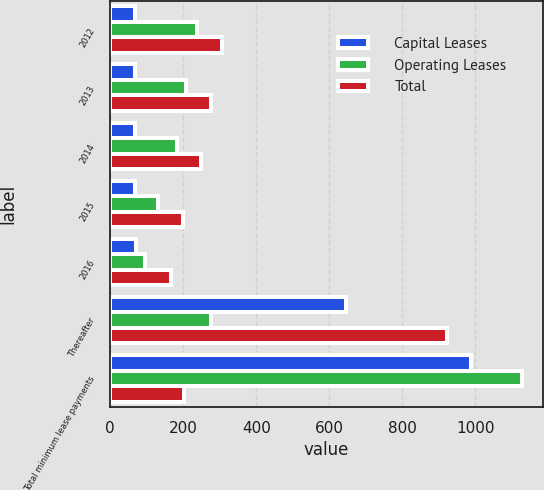Convert chart to OTSL. <chart><loc_0><loc_0><loc_500><loc_500><stacked_bar_chart><ecel><fcel>2012<fcel>2013<fcel>2014<fcel>2015<fcel>2016<fcel>Thereafter<fcel>Total minimum lease payments<nl><fcel>Capital Leases<fcel>68<fcel>68<fcel>68<fcel>67<fcel>71<fcel>647<fcel>989<nl><fcel>Operating Leases<fcel>237<fcel>207<fcel>182<fcel>132<fcel>96<fcel>275<fcel>1129<nl><fcel>Total<fcel>305<fcel>275<fcel>250<fcel>199<fcel>167<fcel>922<fcel>203<nl></chart> 